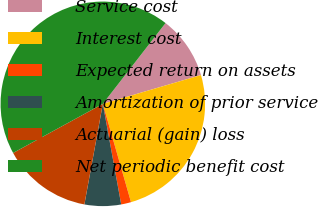Convert chart to OTSL. <chart><loc_0><loc_0><loc_500><loc_500><pie_chart><fcel>Service cost<fcel>Interest cost<fcel>Expected return on assets<fcel>Amortization of prior service<fcel>Actuarial (gain) loss<fcel>Net periodic benefit cost<nl><fcel>9.95%<fcel>25.1%<fcel>1.57%<fcel>5.76%<fcel>14.14%<fcel>43.48%<nl></chart> 